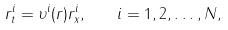Convert formula to latex. <formula><loc_0><loc_0><loc_500><loc_500>r _ { t } ^ { i } = \upsilon ^ { i } ( r ) r _ { x } ^ { i } , \quad i = 1 , 2 , \dots , N ,</formula> 